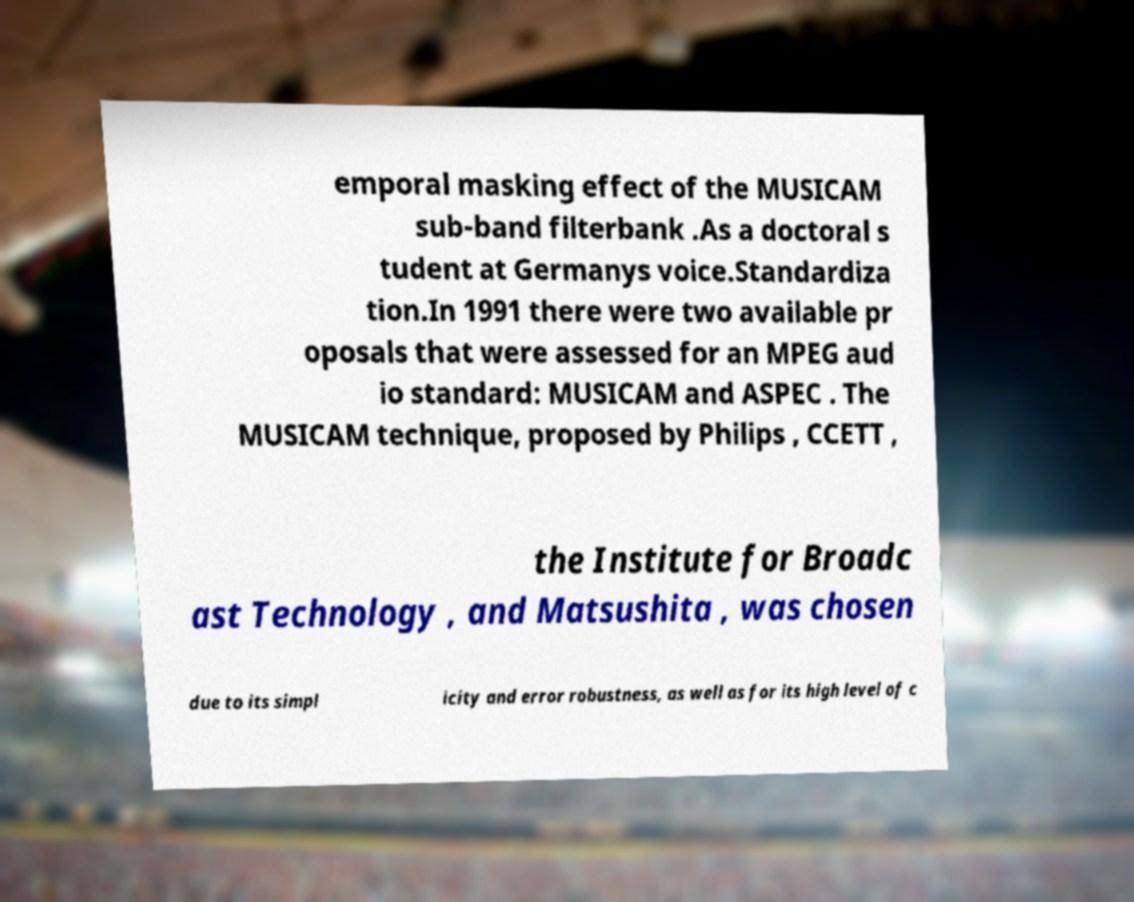Please identify and transcribe the text found in this image. emporal masking effect of the MUSICAM sub-band filterbank .As a doctoral s tudent at Germanys voice.Standardiza tion.In 1991 there were two available pr oposals that were assessed for an MPEG aud io standard: MUSICAM and ASPEC . The MUSICAM technique, proposed by Philips , CCETT , the Institute for Broadc ast Technology , and Matsushita , was chosen due to its simpl icity and error robustness, as well as for its high level of c 